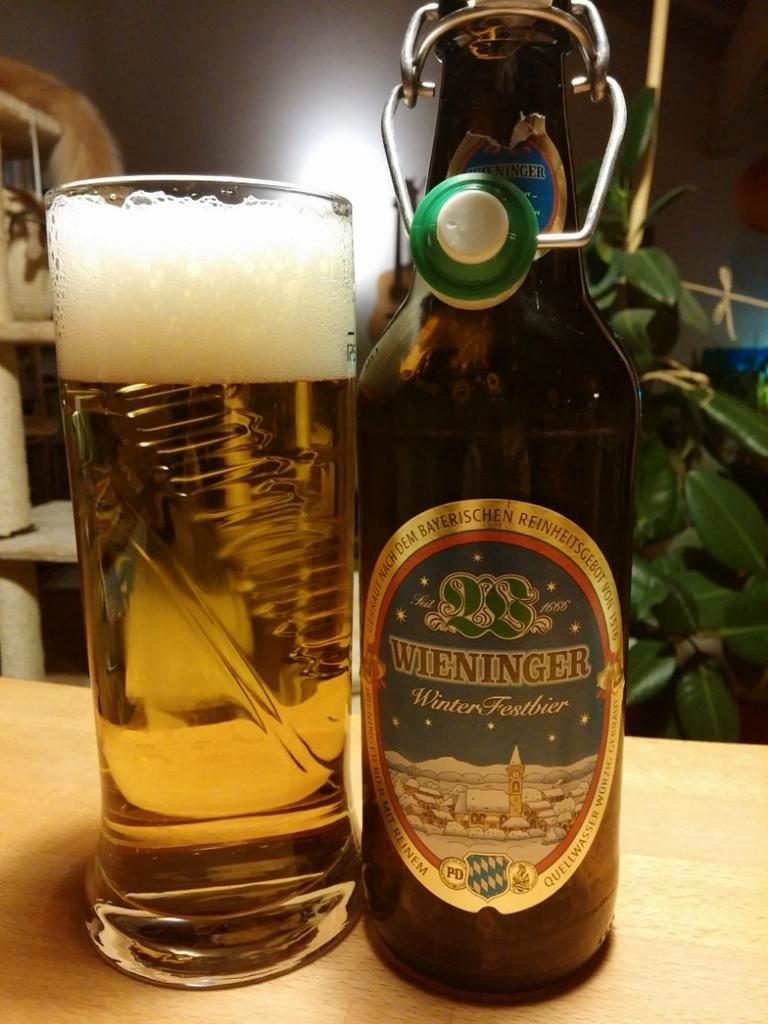Provide a one-sentence caption for the provided image. A bottle of Weininger beer sits by a full glass of beer. 